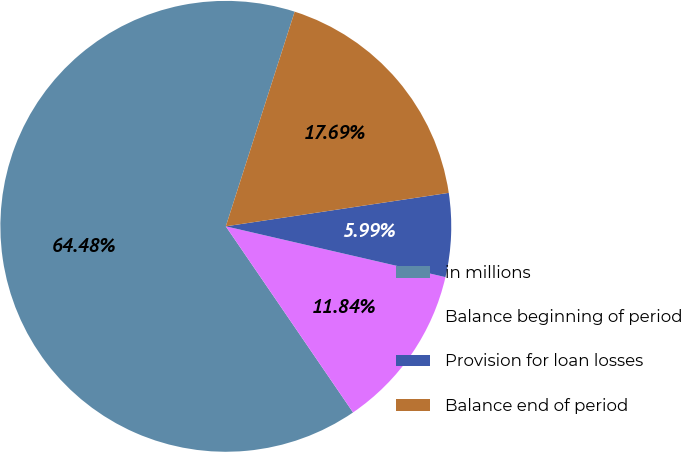Convert chart. <chart><loc_0><loc_0><loc_500><loc_500><pie_chart><fcel>in millions<fcel>Balance beginning of period<fcel>Provision for loan losses<fcel>Balance end of period<nl><fcel>64.49%<fcel>11.84%<fcel>5.99%<fcel>17.69%<nl></chart> 